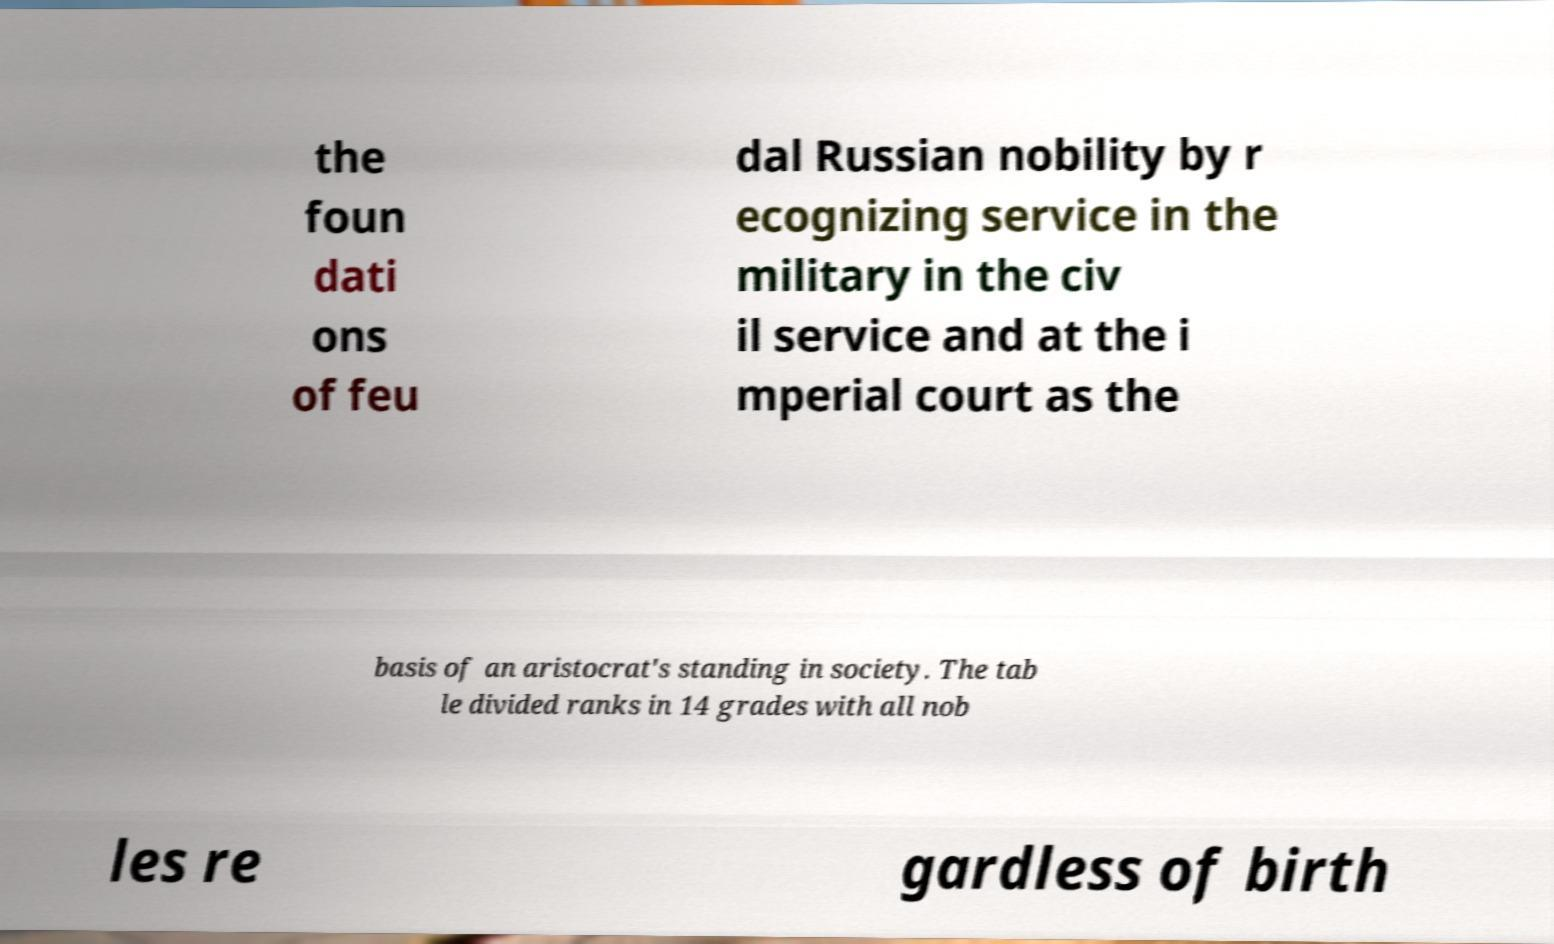There's text embedded in this image that I need extracted. Can you transcribe it verbatim? the foun dati ons of feu dal Russian nobility by r ecognizing service in the military in the civ il service and at the i mperial court as the basis of an aristocrat's standing in society. The tab le divided ranks in 14 grades with all nob les re gardless of birth 